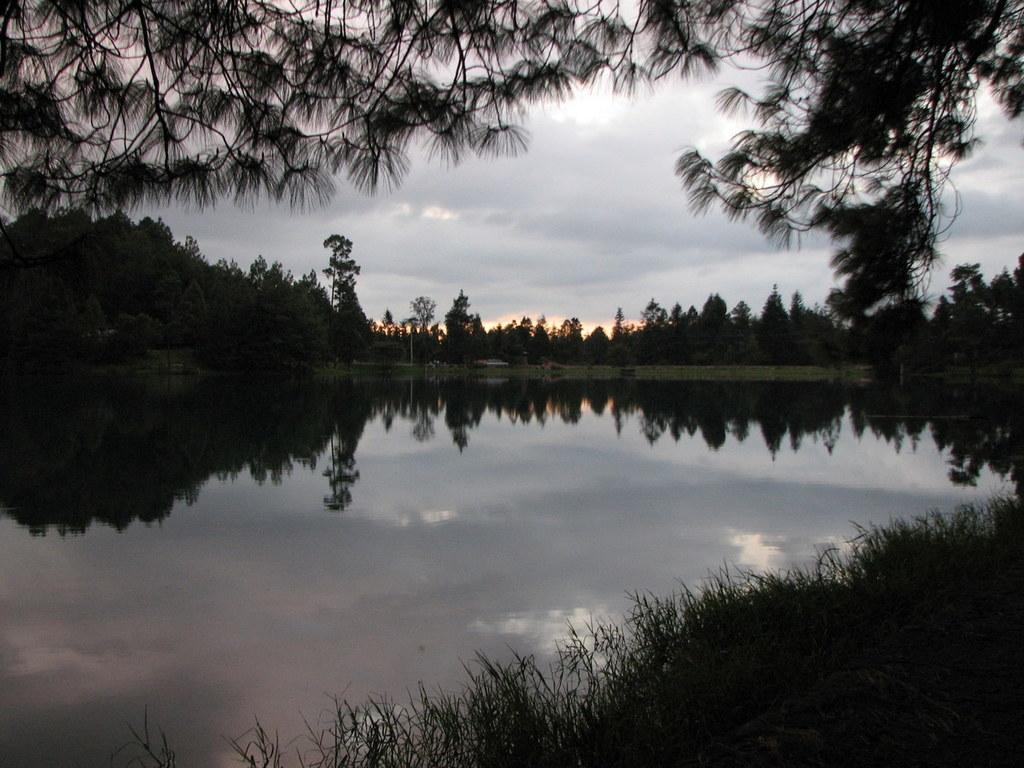What type of vegetation can be seen in the image? There are trees in the image. What else can be seen on the ground in the image? There is grass in the image. What is visible in the water in the image? There are reflections in the water. What is the pole in the image used for? The purpose of the pole in the image is not specified, but it could be a utility pole or a flagpole. What is visible in the sky in the image? There are clouds in the sky in the sky. What flavor of ice cream is being reflected in the water? There is no ice cream present in the image, so there are no flavors to be reflected in the water. 